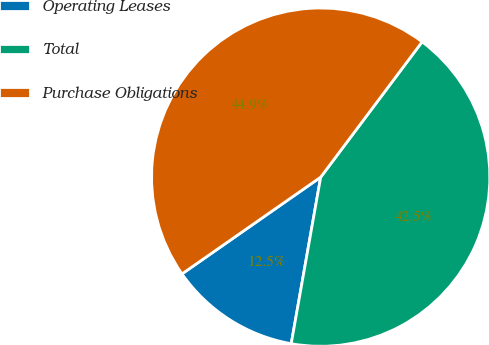Convert chart. <chart><loc_0><loc_0><loc_500><loc_500><pie_chart><fcel>Operating Leases<fcel>Total<fcel>Purchase Obligations<nl><fcel>12.52%<fcel>42.55%<fcel>44.93%<nl></chart> 